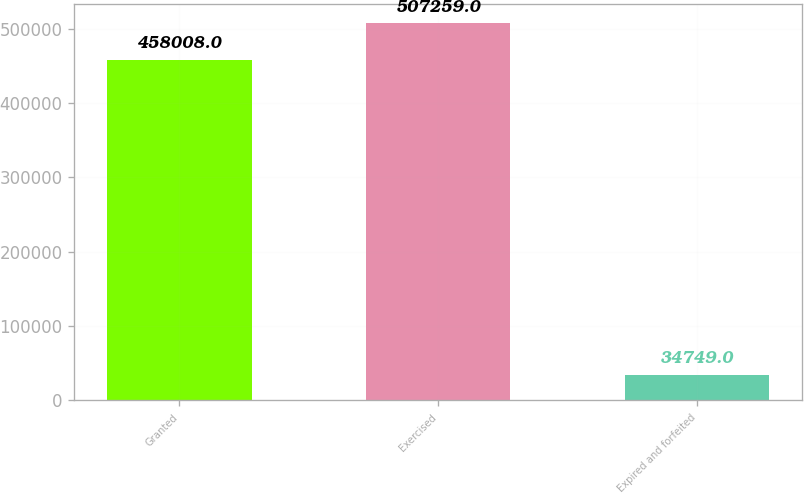Convert chart to OTSL. <chart><loc_0><loc_0><loc_500><loc_500><bar_chart><fcel>Granted<fcel>Exercised<fcel>Expired and forfeited<nl><fcel>458008<fcel>507259<fcel>34749<nl></chart> 